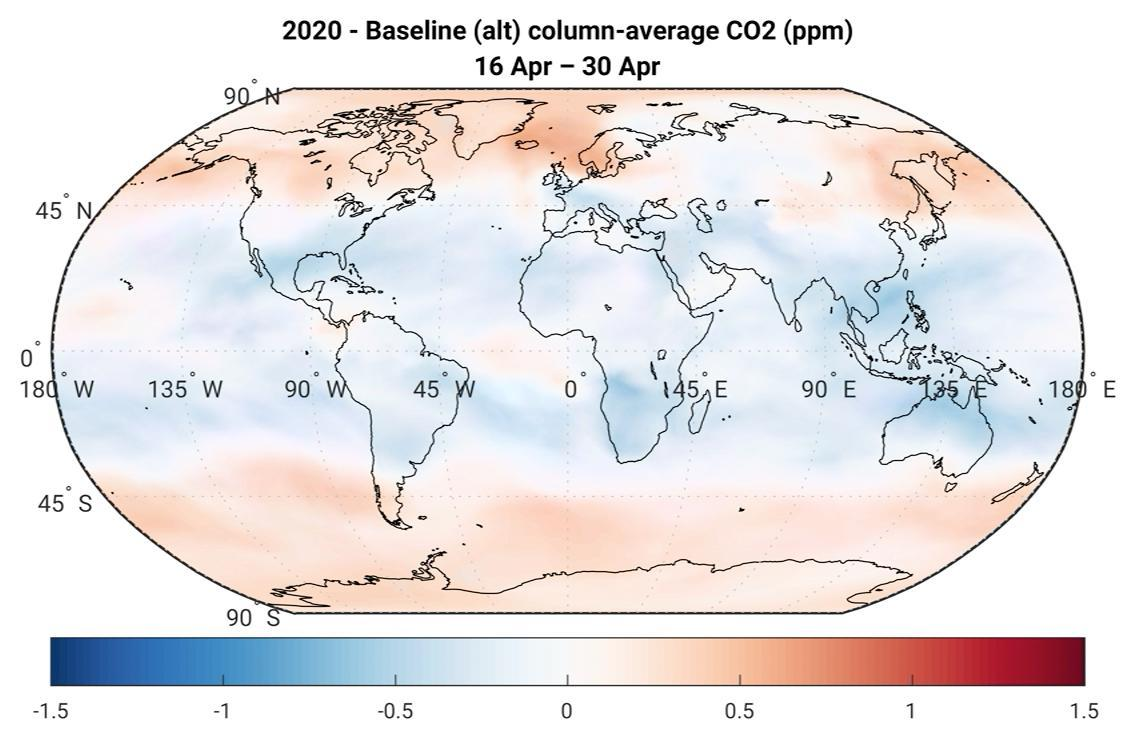What is the colour of the equator region,blue or red
Answer the question with a short phrase. blue What is the colour more prominent on the poles, pink or blue pink 